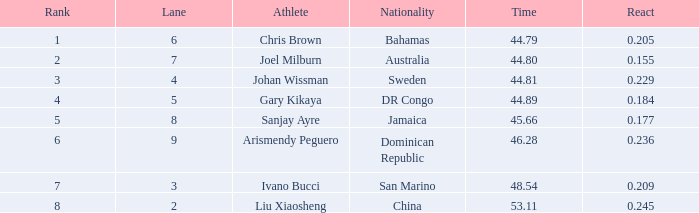209 react submitted with a rank entry that surpasses 6? 2.0. 